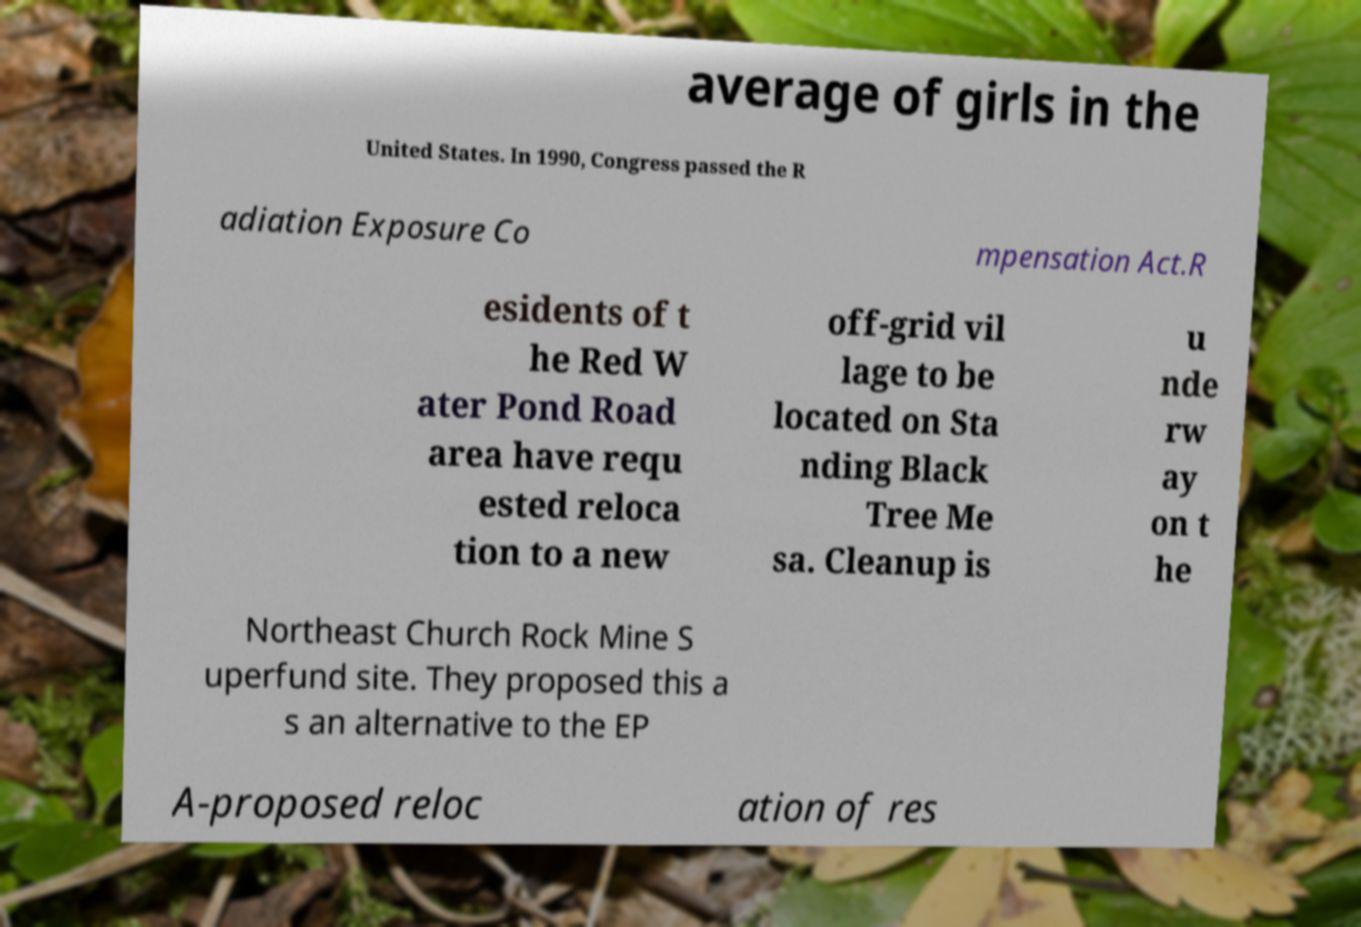Can you accurately transcribe the text from the provided image for me? average of girls in the United States. In 1990, Congress passed the R adiation Exposure Co mpensation Act.R esidents of t he Red W ater Pond Road area have requ ested reloca tion to a new off-grid vil lage to be located on Sta nding Black Tree Me sa. Cleanup is u nde rw ay on t he Northeast Church Rock Mine S uperfund site. They proposed this a s an alternative to the EP A-proposed reloc ation of res 